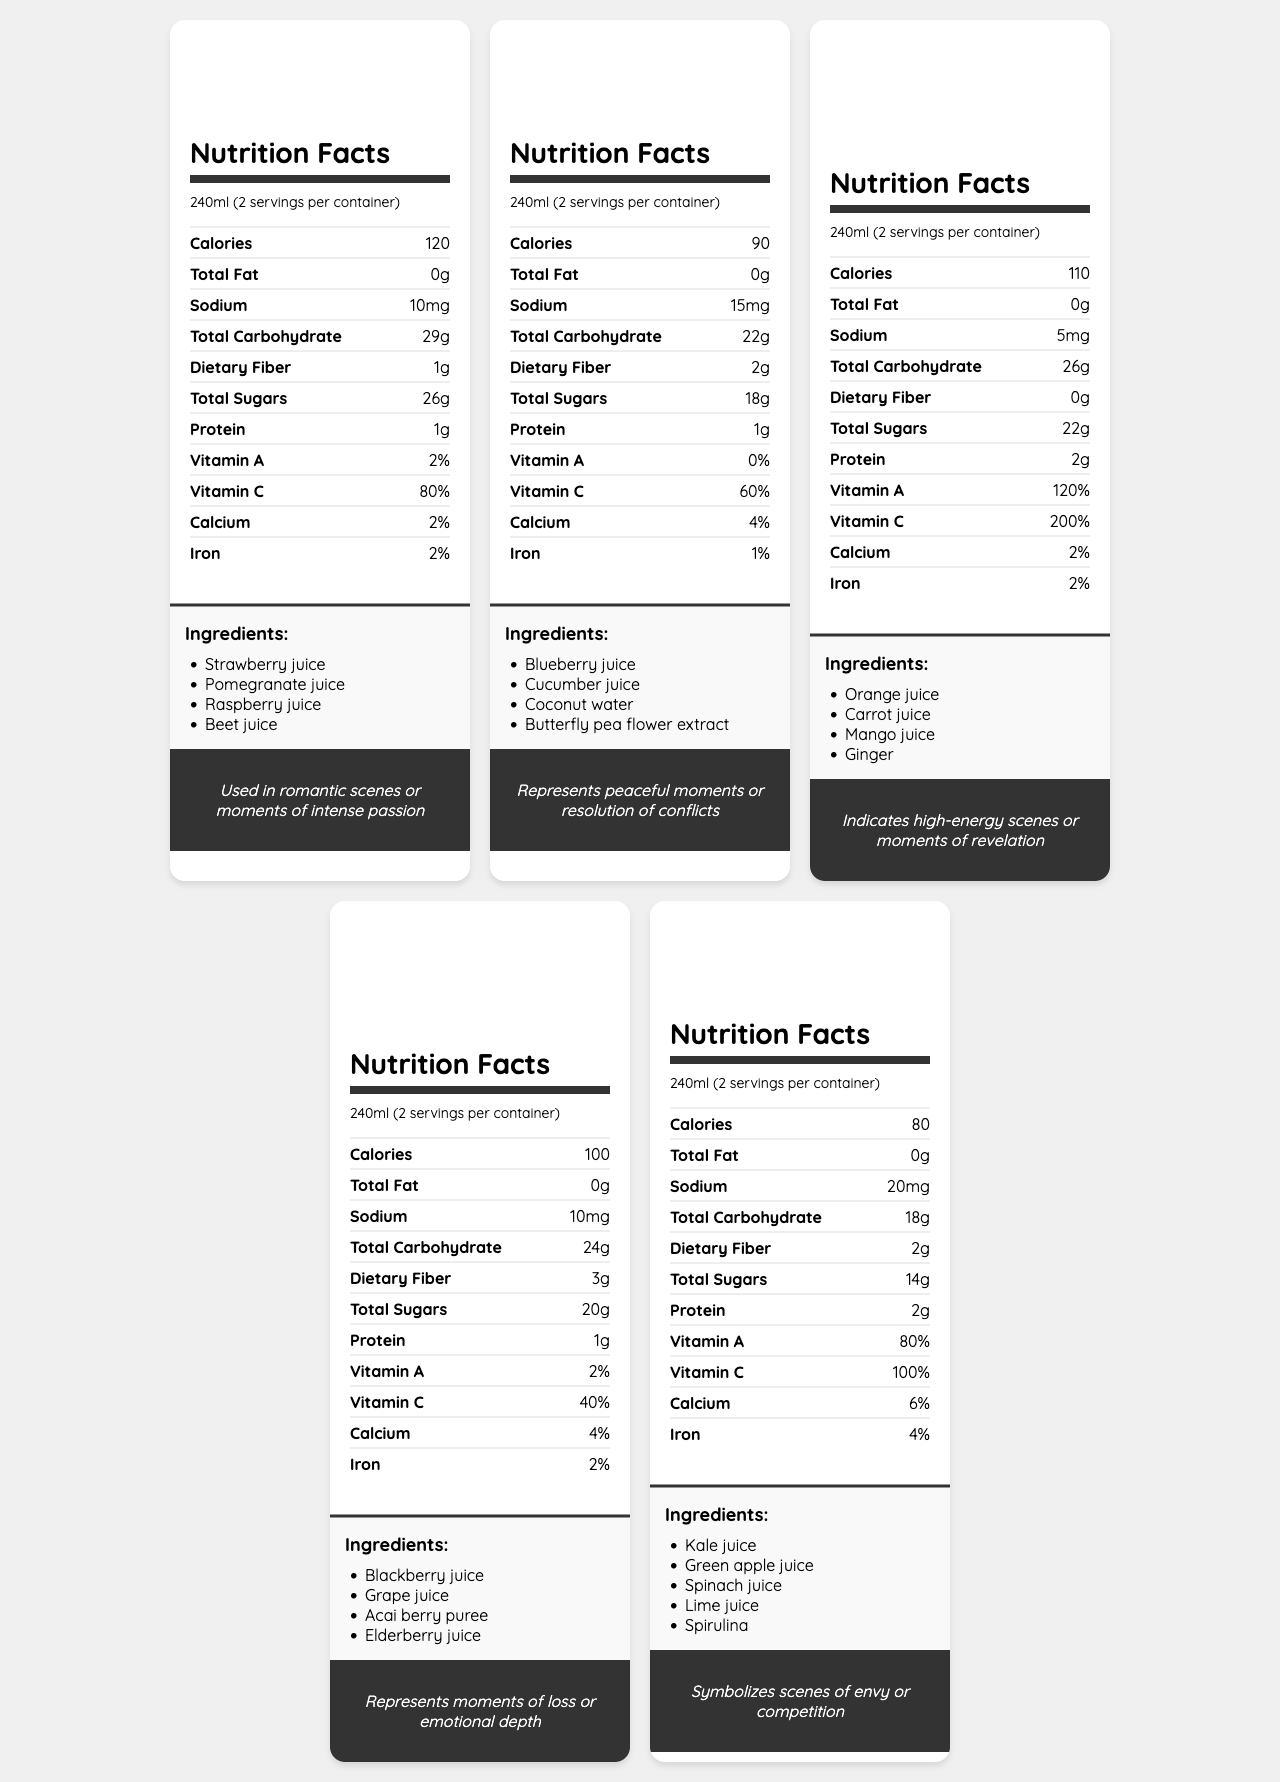what is the serving size of Passion Red Juice? The document lists the serving size for Passion Red Juice as 240ml.
Answer: 240ml what emotion is associated with Serenity Blue Juice? The document states that Serenity Blue Juice corresponds to the emotion "Calm".
Answer: Calm how many servings are there per container of Melancholy Purple Juice? The document indicates that there are 2 servings per container for Melancholy Purple Juice.
Answer: 2 which juice contains Spirulina? The ingredients list for Envy Green Juice includes Spirulina.
Answer: Envy Green Juice what is the calorie content of Energetic Orange Juice per serving? The document states that Energetic Orange Juice has 110 calories per serving.
Answer: 110 calories which juice has the highest percentage of Vitamin C? A. Passion Red Juice B. Serenity Blue Juice C. Energetic Orange Juice D. Melancholy Purple Juice E. Envy Green Juice Energetic Orange Juice contains 200% Vitamin C, which is the highest among all the juices listed.
Answer: C. Energetic Orange Juice which juice would be appropriate to symbolize a moment of competition? A. Passion Red Juice B. Serenity Blue Juice C. Energetic Orange Juice D. Melancholy Purple Juice E. Envy Green Juice The document states that Envy Green Juice symbolizes scenes of envy or competition.
Answer: E. Envy Green Juice do any of the juices contain added sugar? The document does not list "added sugar" under ingredients for any of the juices, implying that the sugars are natural from the fruit.
Answer: No summarize the document. The document elaborates on various juices, each designed with a specific emotion in mind, providing detailed nutritional information, ingredients, and their narrative significance in storytelling, especially in interactive media.
Answer: The document consists of Nutrition Facts Labels for a series of color-coded fruit and vegetable juices, each representing different emotional states. Each juice's nutritional content, ingredients, and serving information are detailed, alongside their associated emotions such as love, calm, excitement, sadness, and jealousy. Additionally, the document highlights how these elements can be used in storytelling within interactive media. what is the daily value percentage of calcium in Melancholy Purple Juice? The document lists the daily value percentage of calcium in Melancholy Purple Juice as 4%.
Answer: 4% how can players interact with the juices in the narrative? The document lists several interactive elements that allow players to mix juices, influence the narrative, and engage in different gameplay mechanics.
Answer: Players can mix juices to create new emotional states, affect character stats or story outcomes, collect rare ingredients, unlock juice recipes, and use color-coded juices in puzzles or dialogue choices. what ingredient in Energetic Orange Juice might symbolize intense stimulation? Ginger is commonly associated with high-energy and stimulating effects, fitting with Energetic Orange Juice's theme of excitement.
Answer: Ginger what are the main emotions represented by the juices? The main emotions conveyed by the juices as per the document are Love, Calm, Excitement, Sadness, and Jealousy.
Answer: Love, Calm, Excitement, Sadness, Jealousy what are the narrative design notes related to the juices? The document lists these narrative design notes, explaining how each aspect of the juices serves to enhance storytelling within a narrative structure.
Answer: The notes include color-emotion correspondence, intensity indicating strength of emotion, mixing juices for complex emotions, nutritional content as metaphors, and ingredients hinting at plot elements. how do the nutritional values of the juices affect the interactive story outcomes? The document mentions that nutritional values can affect story outcomes but does not specify exactly how they do so.
Answer: Cannot be determined 